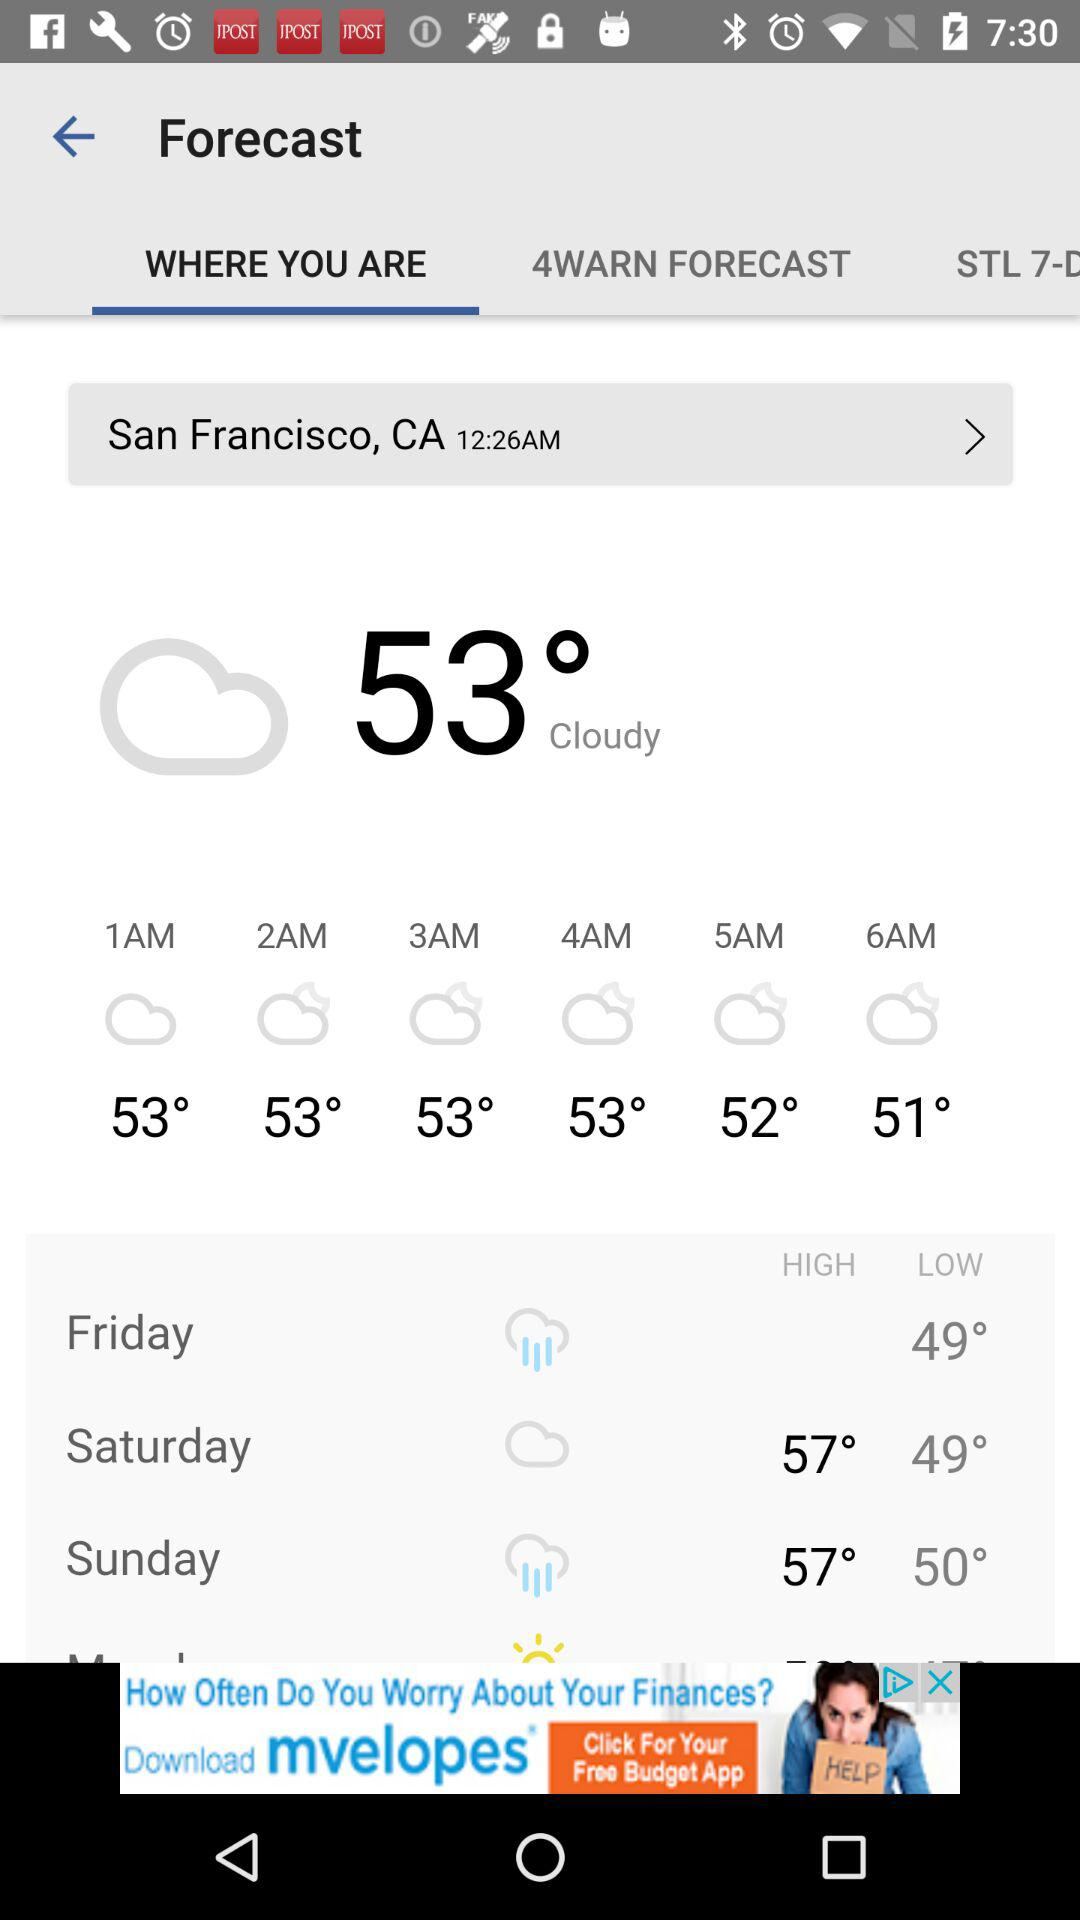What is the current temperature shown on the screen? The current temperature shown on the screen is 53°. 